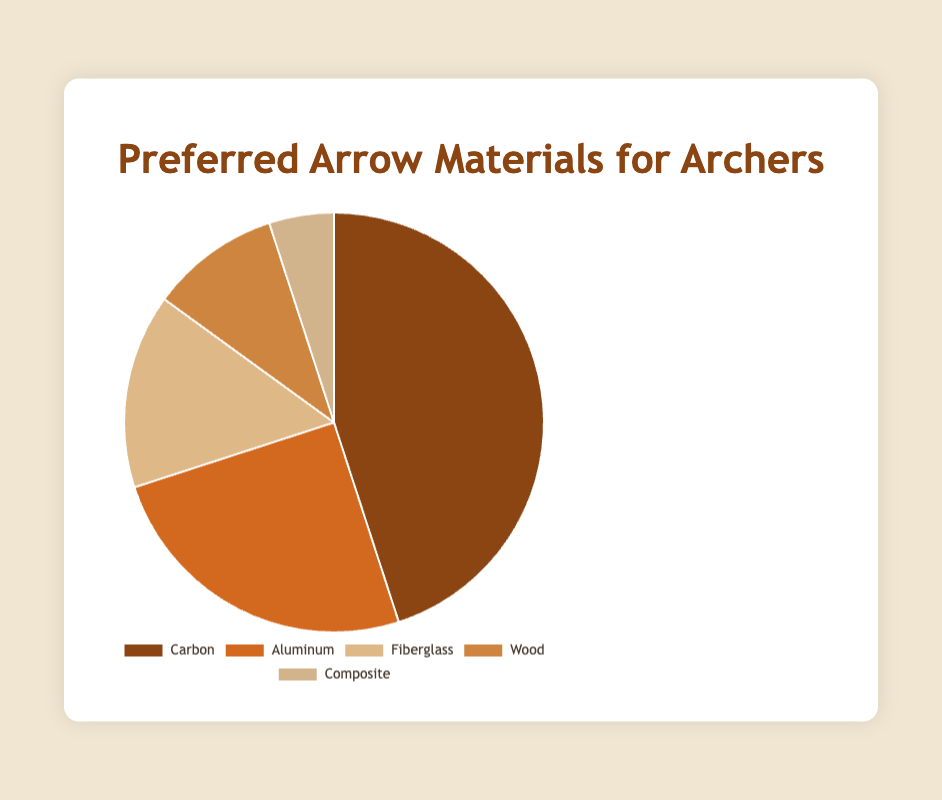Which arrow material is preferred by the highest percentage of archers? The pie chart shows percentages for each arrow material, with Carbon having the largest segment.
Answer: Carbon Which two arrow materials together make up 40% of the total preference? The segments for Aluminum and Fiberglass together total 25% + 15% = 40%.
Answer: Aluminum and Fiberglass What is the percentage difference between the most and least preferred arrow materials? Carbon is the most preferred at 45%, and Composite is the least preferred at 5%. The difference is 45% - 5% = 40%.
Answer: 40% If you combine the preferences for Wood and Composite, what percentage of archers prefer these materials combined? Wood has 10% and Composite has 5%, so combined they make up 10% + 5% = 15%.
Answer: 15% How does the preference for Aluminum compare to the preference for Wood? The pie chart shows Aluminum at 25% and Wood at 10%. Aluminum is more preferred, with a difference of 25% - 10% = 15%.
Answer: Aluminum is preferred by 15% more By how much does the preference for Carbon exceed the combined preference for Fiberglass and Composite? Fiberglass is 15% and Composite is 5%, combined they make 15% + 5% = 20%. Carbon is 45%, so it exceeds the combined by 45% - 20% = 25%.
Answer: 25% Which material is represented by the light brown color slice? Among the colors listed in the dataset, the light brown slice corresponds to Wood.
Answer: Wood What is the average preference percentage for Aluminum, Fiberglass, and Composite? The percentages are 25%, 15%, and 5%. Sum them 25 + 15 + 5 = 45, and divide by 3, (45 / 3 = 15%).
Answer: 15% Which material's preference is equal to the combined preference of Wood and Composite? Wood and Composite together make 10% + 5% = 15%, which is equal to the preference for Fiberglass.
Answer: Fiberglass 